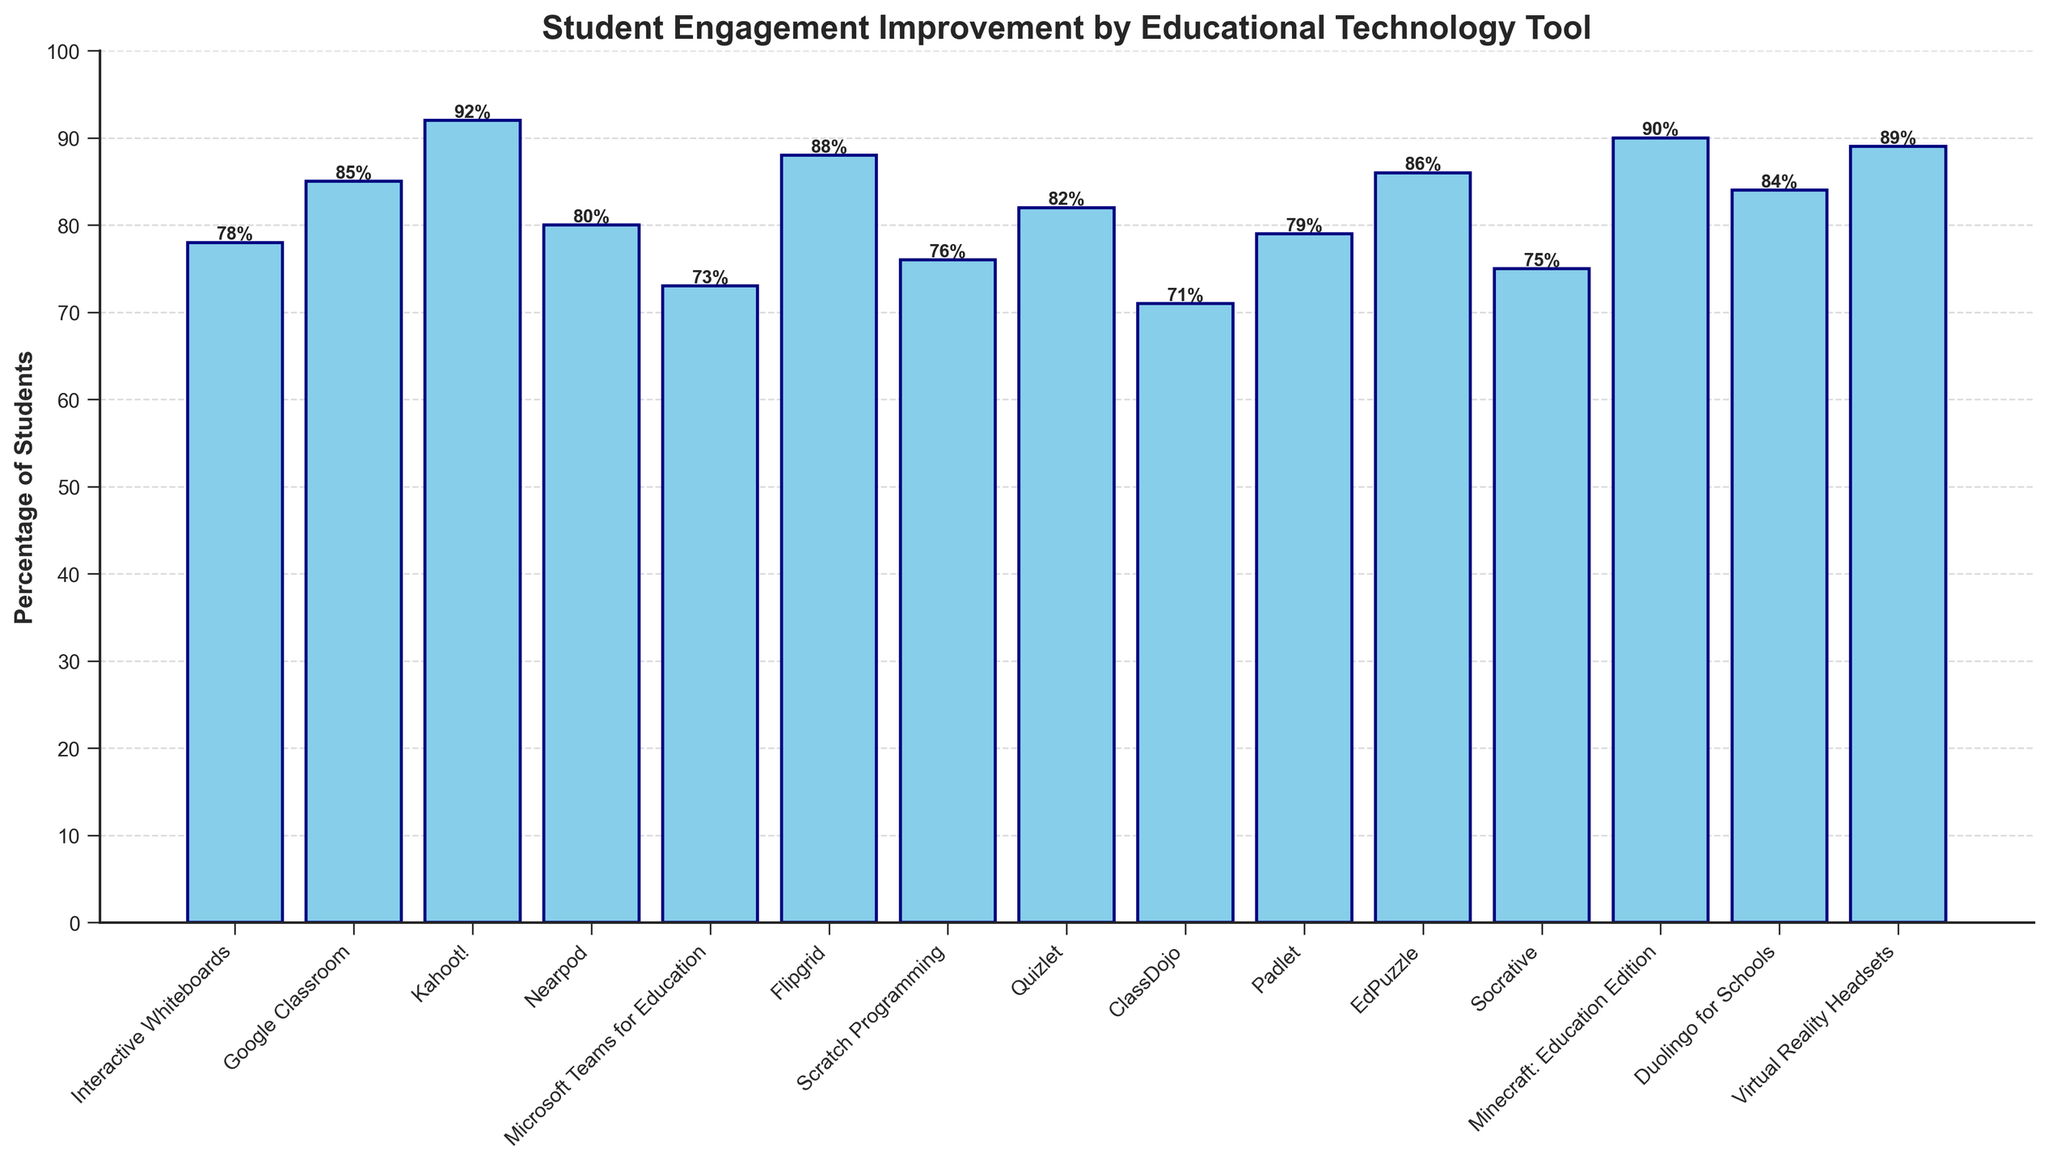Which technology tool shows the highest percentage of student engagement improvement? By observing the heights of all the bars in the chart, the tallest bar represents the highest engagement improvement percentage. The title above this bar will indicate the technology tool.
Answer: Kahoot! What is the percentage of student engagement improvement for Google Classroom and how does it compare with EdPuzzle? First, locate the bars for Google Classroom and EdPuzzle. Google Classroom's height is 85%, while EdPuzzle's is 86%. Then compare the two values.
Answer: 85%, EdPuzzle is 1% higher Which technology tool has the lowest percentage of student engagement improvement? By observing the heights of all the bars in the chart, the shortest bar represents the lowest engagement improvement percentage. The title above this bar will indicate the technology tool.
Answer: ClassDojo What is the average percentage of student engagement improvement across all technology tools? Add up all the percentages for each technology tool (78 + 85 + 92 + 80 + 73 + 88 + 76 + 82 + 71 + 79 + 86 + 75 + 90 + 84 + 89). Divide this sum by the total number of tools (15).
Answer: The sum is 1228, dividing by 15 gives an average of 81.87% Compare the student engagement improvement percentages between Nearpod and Padlet. Which one is higher and by how much? Locate the heights of the bars for Nearpod (80%) and Padlet (79%). Then, subtract the smaller percentage from the larger one.
Answer: Nearpod is 1% higher Which tools have a student engagement improvement percentage above 85%? Identify the bars reaching above the 85% mark. Based on the chart, these tools are Kahoot! (92%), Minecraft: Education Edition (90%), Flipgrid (88%), Virtual Reality Headsets (89%), and EdPuzzle (86%).
Answer: Kahoot!, Minecraft: Education Edition, Flipgrid, Virtual Reality Headsets, EdPuzzle By what percentage does Socrative's engagement improvement differ from Duolingo for Schools? Identify the bars for Socrative (75%) and Duolingo for Schools (84%). Calculate the absolute difference by subtracting 75% from 84%.
Answer: 9% What is the median percentage of student engagement improvement across all technology tools? Arrange the percentages in ascending order and find the middle value. If odd, the middle number. If even, the average of the two middle numbers. The sorted values are: (71, 73, 75, 76, 78, 79, 80, 82, 84, 85, 86, 88, 89, 90, 92). The median is the 8th value.
Answer: 82% How does the percentage improvement of Microsoft Teams for Education compare to the average percentage across all tools? First, calculate the average percentage (81.87%). Then, find Microsoft Teams for Education (73%) and compare it to the average.
Answer: Microsoft Teams for Education is 8.87% lower What is the combined percentage of student engagement improvement for Flipgrid and Quizlet? Add the percentage values for Flipgrid (88%) and Quizlet (82%).
Answer: 170% 